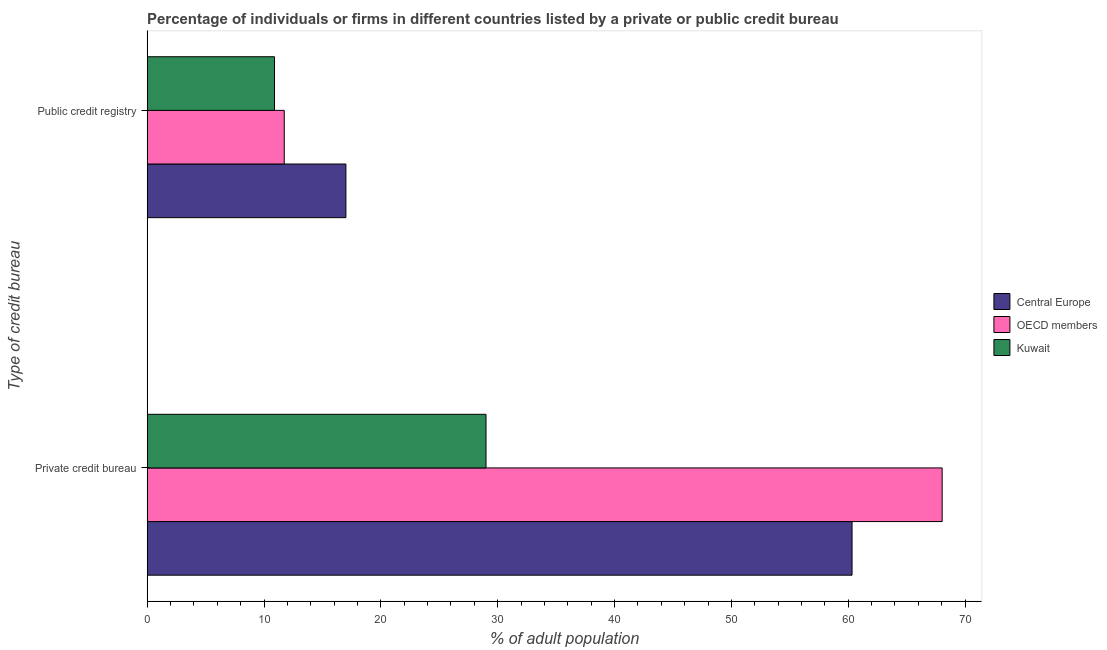How many groups of bars are there?
Your answer should be very brief. 2. How many bars are there on the 1st tick from the top?
Offer a terse response. 3. What is the label of the 1st group of bars from the top?
Offer a very short reply. Public credit registry. What is the percentage of firms listed by private credit bureau in OECD members?
Provide a succinct answer. 68.04. Across all countries, what is the maximum percentage of firms listed by public credit bureau?
Make the answer very short. 17.01. Across all countries, what is the minimum percentage of firms listed by public credit bureau?
Keep it short and to the point. 10.9. In which country was the percentage of firms listed by private credit bureau minimum?
Provide a short and direct response. Kuwait. What is the total percentage of firms listed by private credit bureau in the graph?
Give a very brief answer. 157.37. What is the difference between the percentage of firms listed by public credit bureau in OECD members and that in Central Europe?
Keep it short and to the point. -5.28. What is the difference between the percentage of firms listed by public credit bureau in OECD members and the percentage of firms listed by private credit bureau in Kuwait?
Keep it short and to the point. -17.27. What is the average percentage of firms listed by public credit bureau per country?
Give a very brief answer. 13.21. What is the difference between the percentage of firms listed by public credit bureau and percentage of firms listed by private credit bureau in Central Europe?
Your answer should be compact. -43.32. In how many countries, is the percentage of firms listed by private credit bureau greater than 22 %?
Give a very brief answer. 3. What is the ratio of the percentage of firms listed by private credit bureau in Central Europe to that in OECD members?
Ensure brevity in your answer.  0.89. What does the 3rd bar from the top in Public credit registry represents?
Ensure brevity in your answer.  Central Europe. How many bars are there?
Your answer should be compact. 6. Are all the bars in the graph horizontal?
Provide a succinct answer. Yes. How many countries are there in the graph?
Offer a very short reply. 3. Does the graph contain any zero values?
Provide a short and direct response. No. Does the graph contain grids?
Your answer should be compact. No. How many legend labels are there?
Provide a short and direct response. 3. How are the legend labels stacked?
Make the answer very short. Vertical. What is the title of the graph?
Your answer should be compact. Percentage of individuals or firms in different countries listed by a private or public credit bureau. Does "Nicaragua" appear as one of the legend labels in the graph?
Give a very brief answer. No. What is the label or title of the X-axis?
Ensure brevity in your answer.  % of adult population. What is the label or title of the Y-axis?
Provide a succinct answer. Type of credit bureau. What is the % of adult population of Central Europe in Private credit bureau?
Provide a short and direct response. 60.33. What is the % of adult population of OECD members in Private credit bureau?
Provide a short and direct response. 68.04. What is the % of adult population in Central Europe in Public credit registry?
Offer a terse response. 17.01. What is the % of adult population in OECD members in Public credit registry?
Provide a short and direct response. 11.73. What is the % of adult population in Kuwait in Public credit registry?
Provide a short and direct response. 10.9. Across all Type of credit bureau, what is the maximum % of adult population of Central Europe?
Your answer should be compact. 60.33. Across all Type of credit bureau, what is the maximum % of adult population of OECD members?
Provide a succinct answer. 68.04. Across all Type of credit bureau, what is the minimum % of adult population of Central Europe?
Make the answer very short. 17.01. Across all Type of credit bureau, what is the minimum % of adult population of OECD members?
Offer a terse response. 11.73. Across all Type of credit bureau, what is the minimum % of adult population of Kuwait?
Provide a short and direct response. 10.9. What is the total % of adult population of Central Europe in the graph?
Give a very brief answer. 77.34. What is the total % of adult population of OECD members in the graph?
Provide a short and direct response. 79.77. What is the total % of adult population in Kuwait in the graph?
Provide a short and direct response. 39.9. What is the difference between the % of adult population in Central Europe in Private credit bureau and that in Public credit registry?
Ensure brevity in your answer.  43.32. What is the difference between the % of adult population of OECD members in Private credit bureau and that in Public credit registry?
Provide a succinct answer. 56.31. What is the difference between the % of adult population of Kuwait in Private credit bureau and that in Public credit registry?
Keep it short and to the point. 18.1. What is the difference between the % of adult population in Central Europe in Private credit bureau and the % of adult population in OECD members in Public credit registry?
Make the answer very short. 48.59. What is the difference between the % of adult population in Central Europe in Private credit bureau and the % of adult population in Kuwait in Public credit registry?
Ensure brevity in your answer.  49.43. What is the difference between the % of adult population of OECD members in Private credit bureau and the % of adult population of Kuwait in Public credit registry?
Offer a terse response. 57.14. What is the average % of adult population of Central Europe per Type of credit bureau?
Your response must be concise. 38.67. What is the average % of adult population in OECD members per Type of credit bureau?
Offer a very short reply. 39.89. What is the average % of adult population in Kuwait per Type of credit bureau?
Provide a succinct answer. 19.95. What is the difference between the % of adult population of Central Europe and % of adult population of OECD members in Private credit bureau?
Provide a short and direct response. -7.71. What is the difference between the % of adult population of Central Europe and % of adult population of Kuwait in Private credit bureau?
Offer a terse response. 31.33. What is the difference between the % of adult population in OECD members and % of adult population in Kuwait in Private credit bureau?
Provide a succinct answer. 39.04. What is the difference between the % of adult population of Central Europe and % of adult population of OECD members in Public credit registry?
Provide a succinct answer. 5.28. What is the difference between the % of adult population of Central Europe and % of adult population of Kuwait in Public credit registry?
Your response must be concise. 6.11. What is the difference between the % of adult population of OECD members and % of adult population of Kuwait in Public credit registry?
Ensure brevity in your answer.  0.83. What is the ratio of the % of adult population in Central Europe in Private credit bureau to that in Public credit registry?
Provide a succinct answer. 3.55. What is the ratio of the % of adult population of OECD members in Private credit bureau to that in Public credit registry?
Keep it short and to the point. 5.8. What is the ratio of the % of adult population in Kuwait in Private credit bureau to that in Public credit registry?
Your answer should be very brief. 2.66. What is the difference between the highest and the second highest % of adult population in Central Europe?
Your answer should be compact. 43.32. What is the difference between the highest and the second highest % of adult population in OECD members?
Provide a short and direct response. 56.31. What is the difference between the highest and the second highest % of adult population of Kuwait?
Ensure brevity in your answer.  18.1. What is the difference between the highest and the lowest % of adult population of Central Europe?
Provide a succinct answer. 43.32. What is the difference between the highest and the lowest % of adult population in OECD members?
Offer a very short reply. 56.31. 